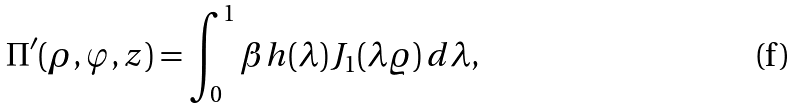<formula> <loc_0><loc_0><loc_500><loc_500>\Pi ^ { \prime } ( \rho , \varphi , z ) = \int ^ { 1 } _ { 0 } \beta h ( \lambda ) J _ { 1 } ( \lambda \varrho ) \, d \lambda ,</formula> 